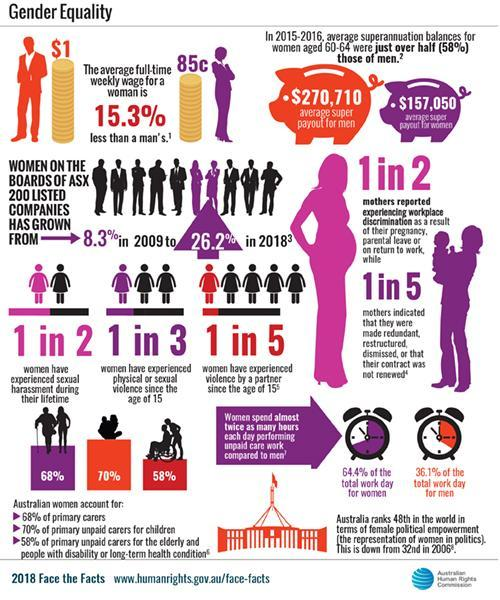What proportion of mothers did not experience any discrimination?
Answer the question with a short phrase. 1 in 2 What is the percentage difference in weekly wage between the two genders? 15.3% What percent of Australian women are primary caretakers of senior citizens? 58% What proportion of women have not faced any form of harassment since the age of 15? 2 in 3 What is the percentage of increase in women on board of ASX listed companies from 2009 to 2018? 17.9% What is the difference in average super payout for men and women? $113,660 